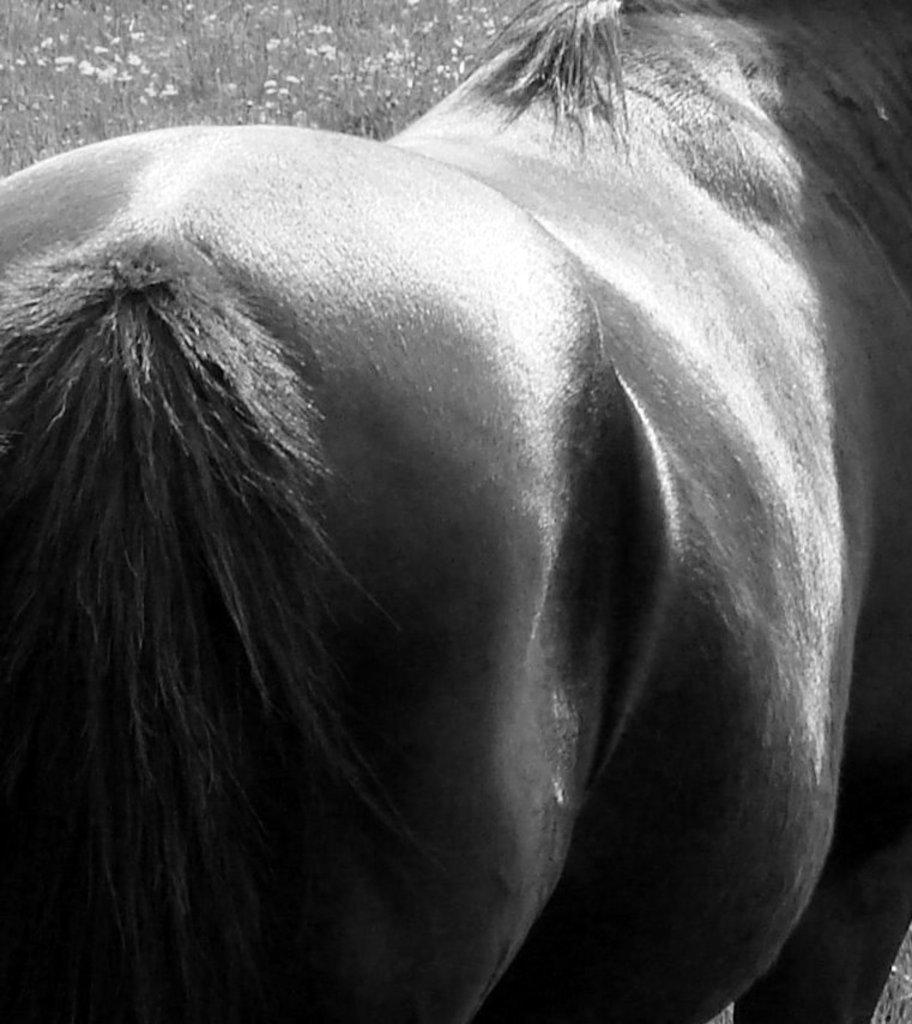Can you describe this image briefly? There is an animal standing. In the background, there are plants having flowers. 